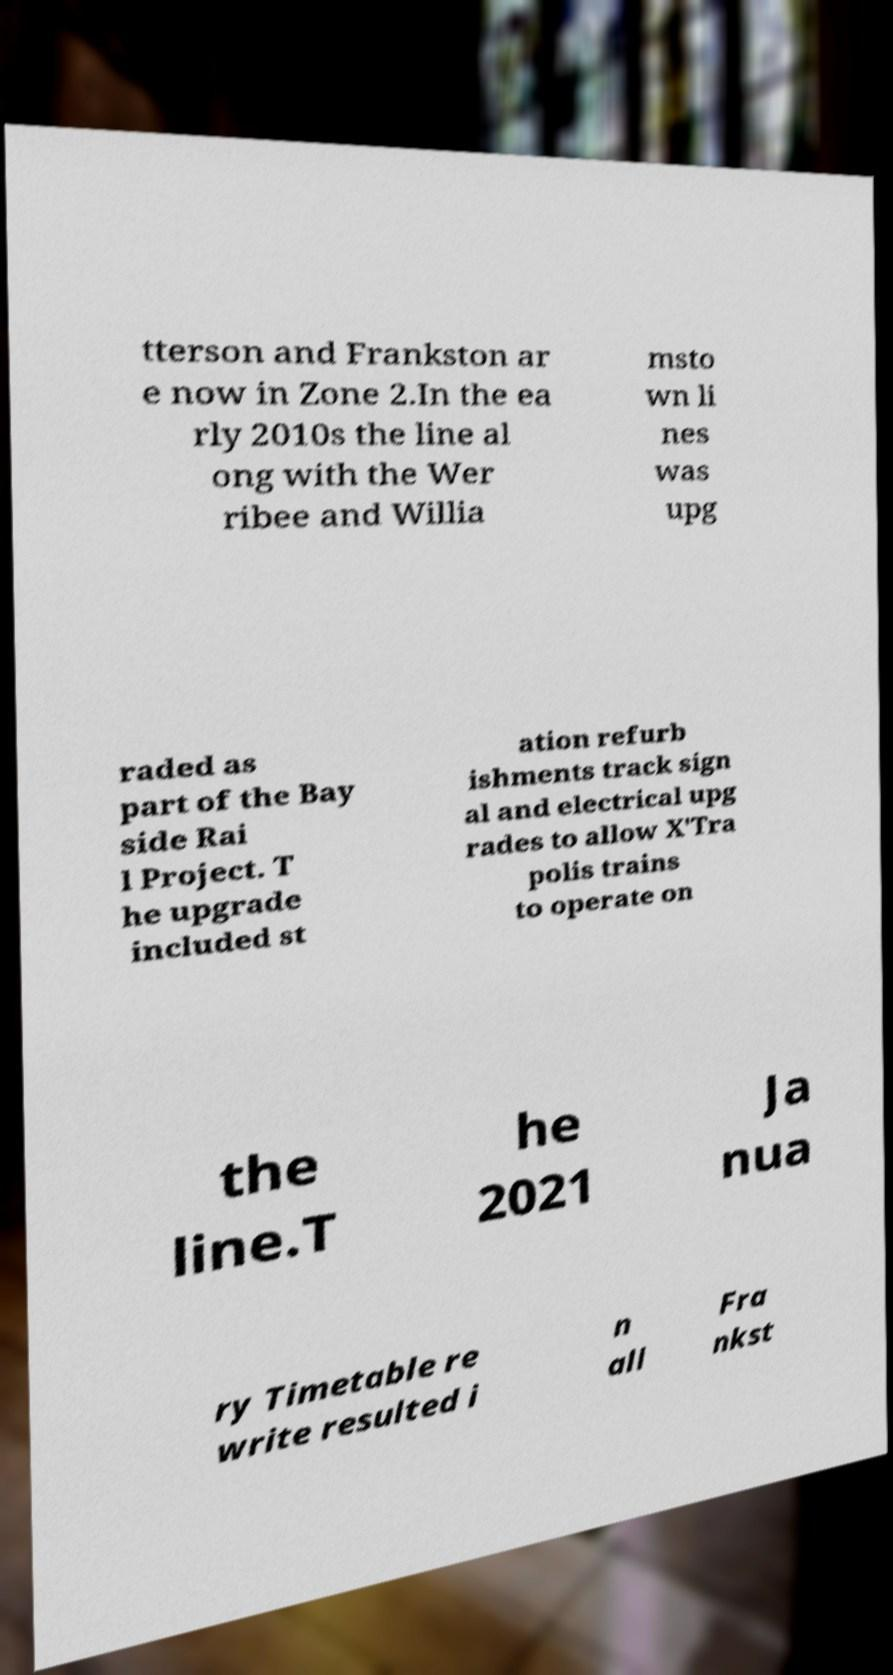What messages or text are displayed in this image? I need them in a readable, typed format. tterson and Frankston ar e now in Zone 2.In the ea rly 2010s the line al ong with the Wer ribee and Willia msto wn li nes was upg raded as part of the Bay side Rai l Project. T he upgrade included st ation refurb ishments track sign al and electrical upg rades to allow X'Tra polis trains to operate on the line.T he 2021 Ja nua ry Timetable re write resulted i n all Fra nkst 